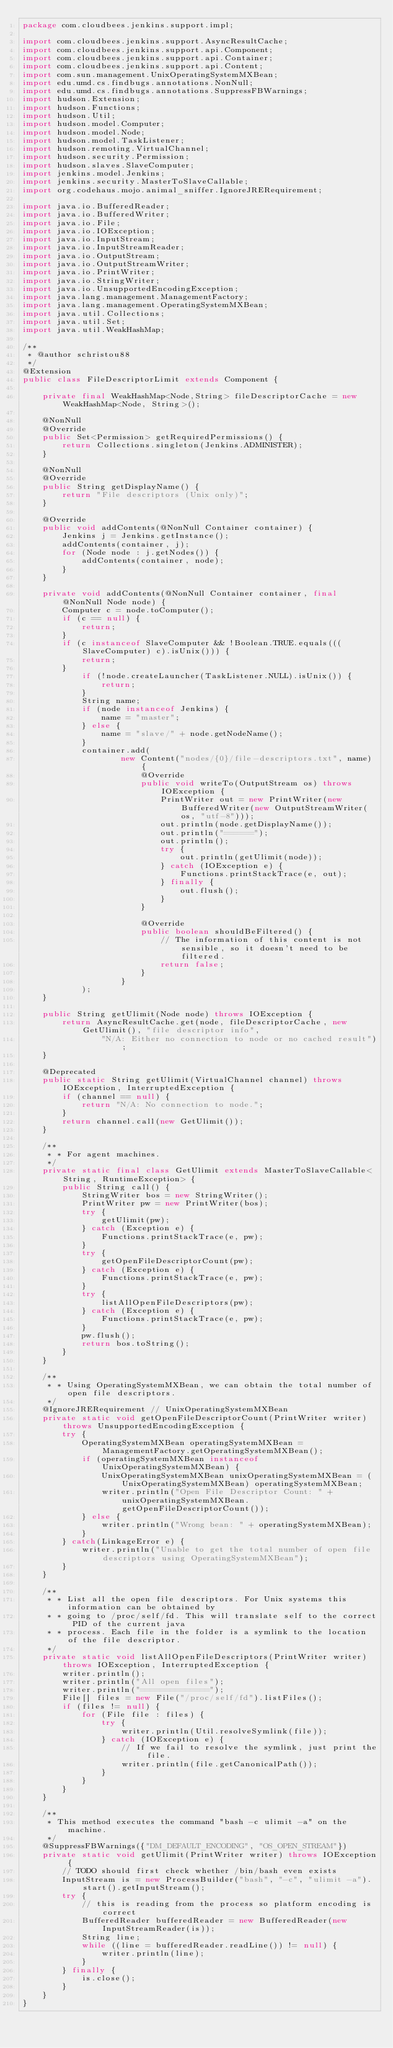Convert code to text. <code><loc_0><loc_0><loc_500><loc_500><_Java_>package com.cloudbees.jenkins.support.impl;

import com.cloudbees.jenkins.support.AsyncResultCache;
import com.cloudbees.jenkins.support.api.Component;
import com.cloudbees.jenkins.support.api.Container;
import com.cloudbees.jenkins.support.api.Content;
import com.sun.management.UnixOperatingSystemMXBean;
import edu.umd.cs.findbugs.annotations.NonNull;
import edu.umd.cs.findbugs.annotations.SuppressFBWarnings;
import hudson.Extension;
import hudson.Functions;
import hudson.Util;
import hudson.model.Computer;
import hudson.model.Node;
import hudson.model.TaskListener;
import hudson.remoting.VirtualChannel;
import hudson.security.Permission;
import hudson.slaves.SlaveComputer;
import jenkins.model.Jenkins;
import jenkins.security.MasterToSlaveCallable;
import org.codehaus.mojo.animal_sniffer.IgnoreJRERequirement;

import java.io.BufferedReader;
import java.io.BufferedWriter;
import java.io.File;
import java.io.IOException;
import java.io.InputStream;
import java.io.InputStreamReader;
import java.io.OutputStream;
import java.io.OutputStreamWriter;
import java.io.PrintWriter;
import java.io.StringWriter;
import java.io.UnsupportedEncodingException;
import java.lang.management.ManagementFactory;
import java.lang.management.OperatingSystemMXBean;
import java.util.Collections;
import java.util.Set;
import java.util.WeakHashMap;

/**
 * @author schristou88
 */
@Extension
public class FileDescriptorLimit extends Component {

    private final WeakHashMap<Node,String> fileDescriptorCache = new WeakHashMap<Node, String>();

    @NonNull
    @Override
    public Set<Permission> getRequiredPermissions() {
        return Collections.singleton(Jenkins.ADMINISTER);
    }

    @NonNull
    @Override
    public String getDisplayName() {
        return "File descriptors (Unix only)";
    }

    @Override
    public void addContents(@NonNull Container container) {
        Jenkins j = Jenkins.getInstance();
        addContents(container, j);
        for (Node node : j.getNodes()) {
            addContents(container, node);
        }
    }

    private void addContents(@NonNull Container container, final @NonNull Node node) {
        Computer c = node.toComputer();
        if (c == null) {
            return;
        }
        if (c instanceof SlaveComputer && !Boolean.TRUE.equals(((SlaveComputer) c).isUnix())) {
            return;
        }
            if (!node.createLauncher(TaskListener.NULL).isUnix()) {
                return;
            }
            String name;
            if (node instanceof Jenkins) {
                name = "master";
            } else {
                name = "slave/" + node.getNodeName();
            }
            container.add(
                    new Content("nodes/{0}/file-descriptors.txt", name) {
                        @Override
                        public void writeTo(OutputStream os) throws IOException {
                            PrintWriter out = new PrintWriter(new BufferedWriter(new OutputStreamWriter(os, "utf-8")));
                            out.println(node.getDisplayName());
                            out.println("======");
                            out.println();
                            try {
                                out.println(getUlimit(node));
                            } catch (IOException e) {
                                Functions.printStackTrace(e, out);
                            } finally {
                                out.flush();
                            }
                        }

                        @Override
                        public boolean shouldBeFiltered() {
                            // The information of this content is not sensible, so it doesn't need to be filtered.
                            return false;
                        }
                    }
            );
    }

    public String getUlimit(Node node) throws IOException {
        return AsyncResultCache.get(node, fileDescriptorCache, new GetUlimit(), "file descriptor info",
                "N/A: Either no connection to node or no cached result");
    }

    @Deprecated
    public static String getUlimit(VirtualChannel channel) throws IOException, InterruptedException {
        if (channel == null) {
            return "N/A: No connection to node.";
        }
        return channel.call(new GetUlimit());
    }

    /**
     * * For agent machines.
     */
    private static final class GetUlimit extends MasterToSlaveCallable<String, RuntimeException> {
        public String call() {
            StringWriter bos = new StringWriter();
            PrintWriter pw = new PrintWriter(bos);
            try {
                getUlimit(pw);
            } catch (Exception e) {
                Functions.printStackTrace(e, pw);
            }
            try {
                getOpenFileDescriptorCount(pw);
            } catch (Exception e) {
                Functions.printStackTrace(e, pw);
            }
            try {
                listAllOpenFileDescriptors(pw);
            } catch (Exception e) {
                Functions.printStackTrace(e, pw);
            }
            pw.flush();
            return bos.toString();
        }
    }

    /**
     * * Using OperatingSystemMXBean, we can obtain the total number of open file descriptors.
     */
    @IgnoreJRERequirement // UnixOperatingSystemMXBean
    private static void getOpenFileDescriptorCount(PrintWriter writer) throws UnsupportedEncodingException {
        try {
            OperatingSystemMXBean operatingSystemMXBean = ManagementFactory.getOperatingSystemMXBean();
            if (operatingSystemMXBean instanceof UnixOperatingSystemMXBean) {
                UnixOperatingSystemMXBean unixOperatingSystemMXBean = (UnixOperatingSystemMXBean) operatingSystemMXBean;
                writer.println("Open File Descriptor Count: " + unixOperatingSystemMXBean.getOpenFileDescriptorCount());
            } else {
                writer.println("Wrong bean: " + operatingSystemMXBean);
            }
        } catch(LinkageError e) {
            writer.println("Unable to get the total number of open file descriptors using OperatingSystemMXBean");
        }
    }

    /**
     * * List all the open file descriptors. For Unix systems this information can be obtained by
     * * going to /proc/self/fd. This will translate self to the correct PID of the current java
     * * process. Each file in the folder is a symlink to the location of the file descriptor.
     */
    private static void listAllOpenFileDescriptors(PrintWriter writer) throws IOException, InterruptedException {
        writer.println();
        writer.println("All open files");
        writer.println("==============");
        File[] files = new File("/proc/self/fd").listFiles();
        if (files != null) {
            for (File file : files) {
                try {
                    writer.println(Util.resolveSymlink(file));
                } catch (IOException e) {
                    // If we fail to resolve the symlink, just print the file.
                    writer.println(file.getCanonicalPath());
                }
            }
        }
    }

    /**
     * This method executes the command "bash -c ulimit -a" on the machine.
     */
    @SuppressFBWarnings({"DM_DEFAULT_ENCODING", "OS_OPEN_STREAM"})
    private static void getUlimit(PrintWriter writer) throws IOException {
        // TODO should first check whether /bin/bash even exists
        InputStream is = new ProcessBuilder("bash", "-c", "ulimit -a").start().getInputStream();
        try {
            // this is reading from the process so platform encoding is correct
            BufferedReader bufferedReader = new BufferedReader(new InputStreamReader(is));
            String line;
            while ((line = bufferedReader.readLine()) != null) {
                writer.println(line);
            }
        } finally {
            is.close();
        }
    }
}
</code> 